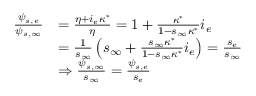<formula> <loc_0><loc_0><loc_500><loc_500>\begin{array} { r l } { \frac { \psi _ { s , e } } { \psi _ { s , \infty } } } & { = \frac { \eta + i _ { e } \kappa ^ { * } } { \eta } = 1 + \frac { \kappa ^ { * } } { 1 - s _ { \infty } \kappa ^ { * } } i _ { e } } \\ & { = \frac { 1 } { s _ { \infty } } \left ( s _ { \infty } + \frac { s _ { \infty } \kappa ^ { * } } { 1 - s _ { \infty } \kappa ^ { * } } i _ { e } \right ) = \frac { s _ { e } } { s _ { \infty } } } \\ & { \Rightarrow \frac { \psi _ { s , \infty } } { s _ { \infty } } = \frac { \psi _ { s , e } } { s _ { e } } } \end{array}</formula> 